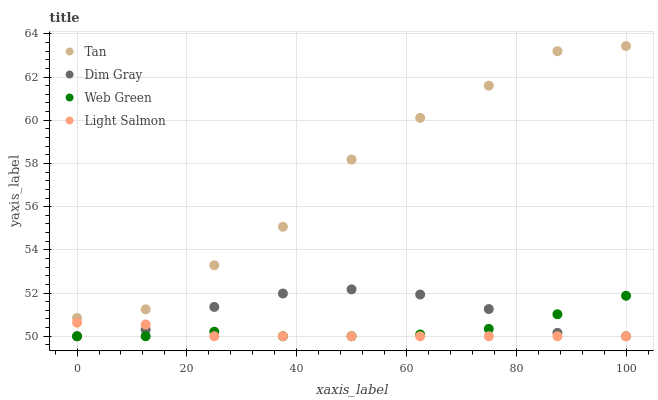Does Light Salmon have the minimum area under the curve?
Answer yes or no. Yes. Does Tan have the maximum area under the curve?
Answer yes or no. Yes. Does Dim Gray have the minimum area under the curve?
Answer yes or no. No. Does Dim Gray have the maximum area under the curve?
Answer yes or no. No. Is Light Salmon the smoothest?
Answer yes or no. Yes. Is Tan the roughest?
Answer yes or no. Yes. Is Dim Gray the smoothest?
Answer yes or no. No. Is Dim Gray the roughest?
Answer yes or no. No. Does Dim Gray have the lowest value?
Answer yes or no. Yes. Does Tan have the highest value?
Answer yes or no. Yes. Does Dim Gray have the highest value?
Answer yes or no. No. Is Dim Gray less than Tan?
Answer yes or no. Yes. Is Tan greater than Web Green?
Answer yes or no. Yes. Does Light Salmon intersect Dim Gray?
Answer yes or no. Yes. Is Light Salmon less than Dim Gray?
Answer yes or no. No. Is Light Salmon greater than Dim Gray?
Answer yes or no. No. Does Dim Gray intersect Tan?
Answer yes or no. No. 